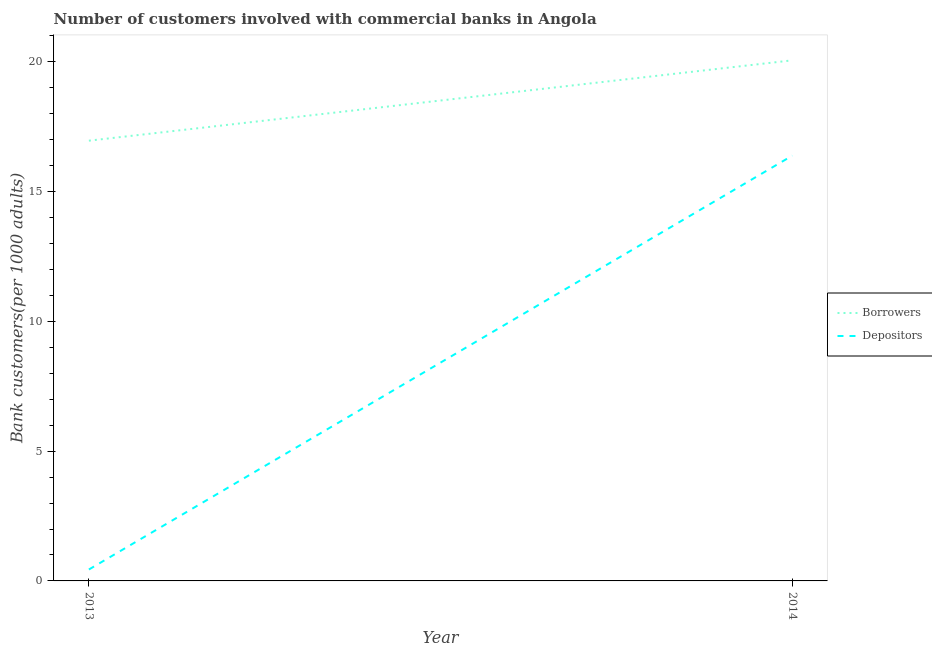How many different coloured lines are there?
Your answer should be compact. 2. Does the line corresponding to number of borrowers intersect with the line corresponding to number of depositors?
Provide a succinct answer. No. Is the number of lines equal to the number of legend labels?
Provide a succinct answer. Yes. What is the number of borrowers in 2013?
Provide a short and direct response. 16.96. Across all years, what is the maximum number of depositors?
Provide a succinct answer. 16.39. Across all years, what is the minimum number of depositors?
Your answer should be very brief. 0.44. In which year was the number of borrowers maximum?
Keep it short and to the point. 2014. In which year was the number of depositors minimum?
Provide a succinct answer. 2013. What is the total number of depositors in the graph?
Your response must be concise. 16.83. What is the difference between the number of depositors in 2013 and that in 2014?
Make the answer very short. -15.95. What is the difference between the number of borrowers in 2013 and the number of depositors in 2014?
Your response must be concise. 0.58. What is the average number of depositors per year?
Make the answer very short. 8.41. In the year 2014, what is the difference between the number of borrowers and number of depositors?
Offer a very short reply. 3.67. What is the ratio of the number of depositors in 2013 to that in 2014?
Ensure brevity in your answer.  0.03. Does the number of borrowers monotonically increase over the years?
Give a very brief answer. Yes. How many years are there in the graph?
Keep it short and to the point. 2. What is the difference between two consecutive major ticks on the Y-axis?
Offer a very short reply. 5. Are the values on the major ticks of Y-axis written in scientific E-notation?
Make the answer very short. No. Does the graph contain any zero values?
Give a very brief answer. No. Does the graph contain grids?
Give a very brief answer. No. How many legend labels are there?
Provide a short and direct response. 2. How are the legend labels stacked?
Your answer should be compact. Vertical. What is the title of the graph?
Your answer should be compact. Number of customers involved with commercial banks in Angola. Does "Banks" appear as one of the legend labels in the graph?
Ensure brevity in your answer.  No. What is the label or title of the X-axis?
Give a very brief answer. Year. What is the label or title of the Y-axis?
Offer a terse response. Bank customers(per 1000 adults). What is the Bank customers(per 1000 adults) in Borrowers in 2013?
Give a very brief answer. 16.96. What is the Bank customers(per 1000 adults) of Depositors in 2013?
Provide a succinct answer. 0.44. What is the Bank customers(per 1000 adults) in Borrowers in 2014?
Give a very brief answer. 20.06. What is the Bank customers(per 1000 adults) of Depositors in 2014?
Offer a terse response. 16.39. Across all years, what is the maximum Bank customers(per 1000 adults) in Borrowers?
Make the answer very short. 20.06. Across all years, what is the maximum Bank customers(per 1000 adults) in Depositors?
Provide a short and direct response. 16.39. Across all years, what is the minimum Bank customers(per 1000 adults) in Borrowers?
Keep it short and to the point. 16.96. Across all years, what is the minimum Bank customers(per 1000 adults) in Depositors?
Offer a terse response. 0.44. What is the total Bank customers(per 1000 adults) of Borrowers in the graph?
Offer a terse response. 37.02. What is the total Bank customers(per 1000 adults) in Depositors in the graph?
Make the answer very short. 16.83. What is the difference between the Bank customers(per 1000 adults) in Borrowers in 2013 and that in 2014?
Provide a short and direct response. -3.1. What is the difference between the Bank customers(per 1000 adults) in Depositors in 2013 and that in 2014?
Your response must be concise. -15.95. What is the difference between the Bank customers(per 1000 adults) in Borrowers in 2013 and the Bank customers(per 1000 adults) in Depositors in 2014?
Provide a succinct answer. 0.58. What is the average Bank customers(per 1000 adults) of Borrowers per year?
Ensure brevity in your answer.  18.51. What is the average Bank customers(per 1000 adults) in Depositors per year?
Ensure brevity in your answer.  8.41. In the year 2013, what is the difference between the Bank customers(per 1000 adults) in Borrowers and Bank customers(per 1000 adults) in Depositors?
Provide a succinct answer. 16.52. In the year 2014, what is the difference between the Bank customers(per 1000 adults) of Borrowers and Bank customers(per 1000 adults) of Depositors?
Provide a succinct answer. 3.67. What is the ratio of the Bank customers(per 1000 adults) of Borrowers in 2013 to that in 2014?
Keep it short and to the point. 0.85. What is the ratio of the Bank customers(per 1000 adults) in Depositors in 2013 to that in 2014?
Provide a succinct answer. 0.03. What is the difference between the highest and the second highest Bank customers(per 1000 adults) in Borrowers?
Offer a terse response. 3.1. What is the difference between the highest and the second highest Bank customers(per 1000 adults) of Depositors?
Provide a succinct answer. 15.95. What is the difference between the highest and the lowest Bank customers(per 1000 adults) of Borrowers?
Offer a terse response. 3.1. What is the difference between the highest and the lowest Bank customers(per 1000 adults) of Depositors?
Offer a very short reply. 15.95. 